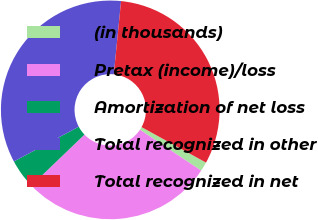Convert chart. <chart><loc_0><loc_0><loc_500><loc_500><pie_chart><fcel>(in thousands)<fcel>Pretax (income)/loss<fcel>Amortization of net loss<fcel>Total recognized in other<fcel>Total recognized in net<nl><fcel>1.37%<fcel>28.45%<fcel>4.35%<fcel>34.4%<fcel>31.43%<nl></chart> 